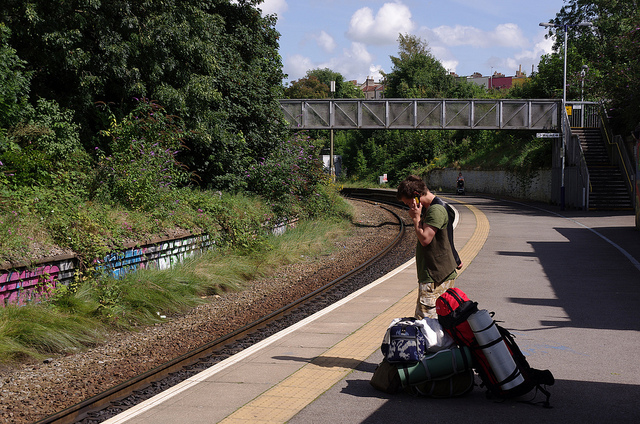If the person decided to take a break, what nearby facilities might they look for? If the person decides to take a break, they might look for nearby facilities such as waiting benches, a café or snack bar, restrooms, and possibly a small convenience store where they can purchase additional supplies or refreshments. 